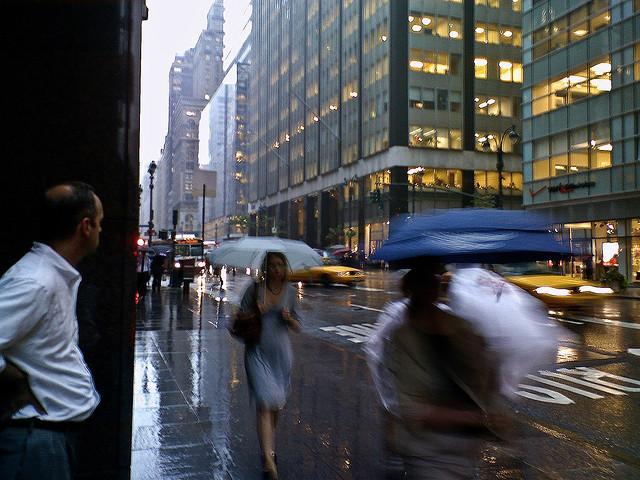What is the man wearing white shirt waiting for? taxi 